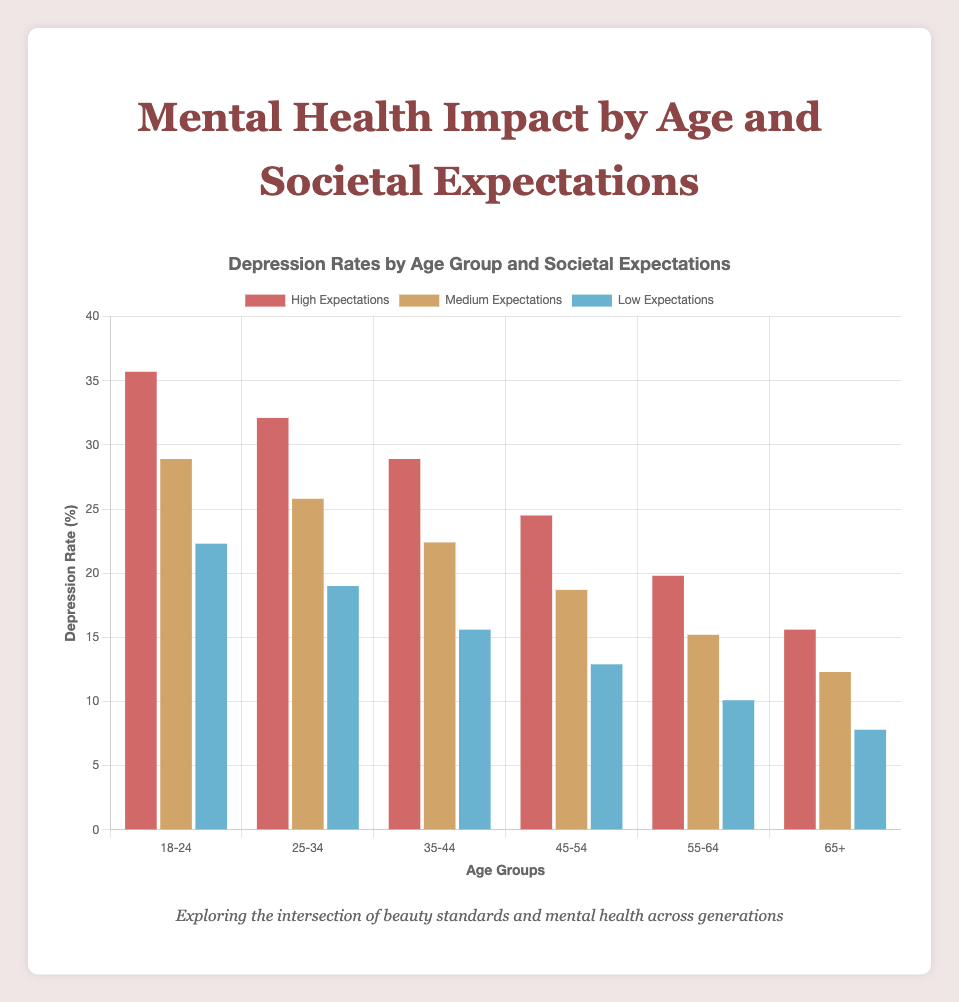What is the depression rate for the age group 18-24 with high societal expectations? Look at the height of the bar corresponding to the age group 18-24 and high societal expectations. The depression rate is shown at the top of the bar.
Answer: 35.7% Which age group experiences the highest depression rate under medium societal expectations? Compare the height of the bars for the 'medium' societal expectations across all age groups. The tallest bar indicates the highest depression rate.
Answer: 18-24 How much higher is the depression rate for age group 25-34 with high societal expectations compared to low societal expectations in the same age group? Find the depression rates for age group 25-34 under high and low societal expectations. Subtract the low expectation rate (19.0%) from the high expectation rate (32.1%)
Answer: 13.1% What is the average depression rate in the age group 35-44 across all levels of societal expectations? Calculate the average of the depression rates for age group 35-44: (28.9% for high + 22.4% for medium + 15.6% for low) / 3
Answer: 22.3% Depression rates for which age group show the least impact by societal expectations? Identify the age group with the smallest difference between the highest and lowest depression rates across different societal expectations by calculating the range: (highest rate - lowest rate). The group with the smallest range has the least impact.
Answer: 65+ Does any age group have a lower depression rate under high societal expectations than age group 18-24 has under medium societal expectations? Find the depression rate for age group 18-24 under medium expectations (28.9%). Compare it with the depression rates for all other age groups under high expectations. Check if any are lower.
Answer: Yes, 55-64 and 65+ Which color represents the lowest depression rate in age group 45-54? Look at the bars for age group 45-54 and identify the color representing the bar with the lowest height.
Answer: Blue What is the total depression rate for all age groups under low societal expectations? Sum the depression rates for all age groups under low societal expectations: 22.3% (18-24) + 19.0% (25-34) + 15.6% (35-44) + 12.9% (45-54) + 10.1% (55-64) + 7.8% (65+)
Answer: 87.7% How does the depression rate change as the age increases under high societal expectations? Observe the trend of the heights of the bars representing high societal expectations as the age groups progress from 18-24 to 65+.
Answer: It decreases Is the depression rate for age group 55-64 under medium societal expectations higher or lower than depression rate for age group 35-44 under low societal expectations? Compare the heights of the bars: medium for age group 55-64 (15.2%) and low for age group 35-44 (15.6%).
Answer: Lower 